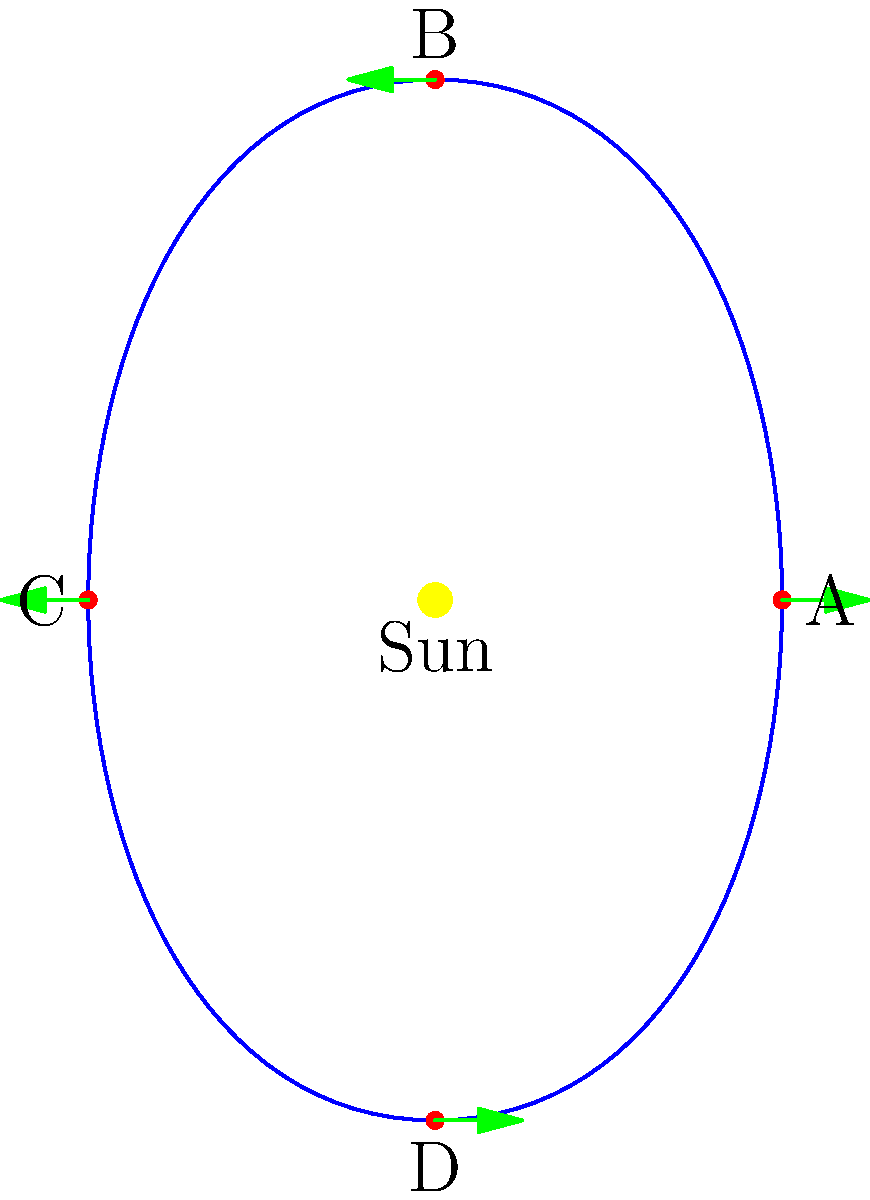As a television producer covering a space-themed event, you need to explain the motion of a comet around the Sun to your audience. The image shows a comet's elliptical orbit around the Sun, with the comet's position marked at four points (A, B, C, and D). Green arrows indicate the comet's velocity direction at each point. At which point is the comet moving fastest, and how does this relate to its distance from the Sun? To answer this question, we need to consider Kepler's laws of planetary motion, which also apply to comets:

1. Kepler's First Law: The orbit of a planet (or comet) around the Sun is an ellipse, with the Sun at one of the two foci.

2. Kepler's Second Law: A line segment joining a planet (or comet) and the Sun sweeps out equal areas during equal intervals of time.

3. Kepler's Third Law: The square of the orbital period of a planet is directly proportional to the cube of the semi-major axis of its orbit.

For this question, we focus on Kepler's Second Law, also known as the law of equal areas. This law implies that the comet's speed is not constant throughout its orbit. The comet moves faster when it's closer to the Sun and slower when it's farther away.

Analyzing the points in the image:

- Point A: The comet is closest to the Sun (perihelion). This is where the comet's speed is greatest.
- Point C: The comet is farthest from the Sun (aphelion). This is where the comet's speed is slowest.
- Points B and D: The comet is at intermediate distances from the Sun, with intermediate speeds.

The reason for this variation in speed is the Sun's gravitational pull. When the comet is closer to the Sun, the gravitational force is stronger, causing the comet to accelerate. As it moves away from the Sun, it slows down due to the weaker gravitational pull.

This relationship between speed and distance is described mathematically by the vis-viva equation:

$$v^2 = GM\left(\frac{2}{r} - \frac{1}{a}\right)$$

Where:
$v$ is the speed of the comet
$G$ is the gravitational constant
$M$ is the mass of the Sun
$r$ is the distance from the Sun
$a$ is the semi-major axis of the orbit

As $r$ decreases, $v$ increases, and vice versa.
Answer: Point A; closest to Sun 